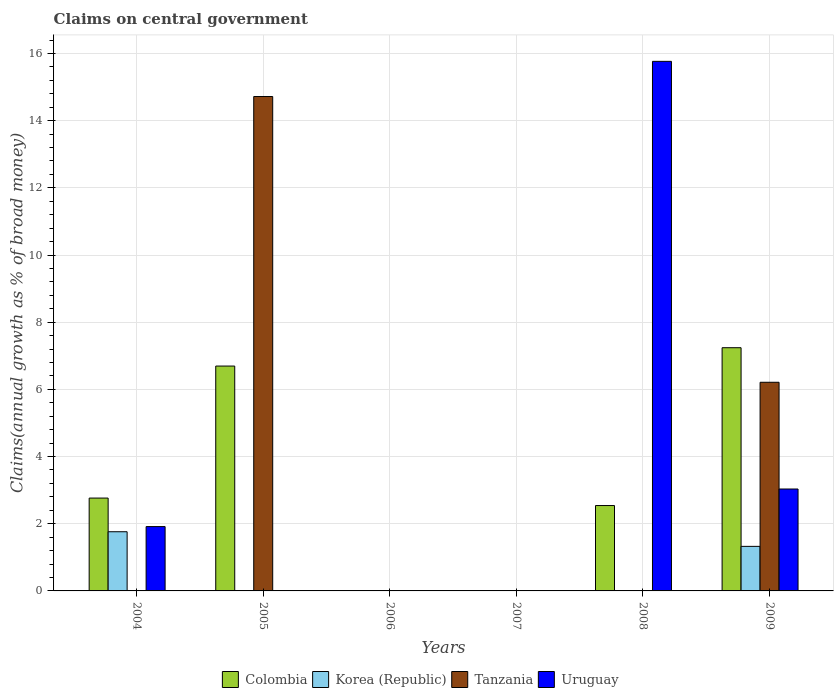How many different coloured bars are there?
Offer a terse response. 4. Are the number of bars per tick equal to the number of legend labels?
Your answer should be very brief. No. Are the number of bars on each tick of the X-axis equal?
Your answer should be compact. No. How many bars are there on the 4th tick from the right?
Your answer should be compact. 0. Across all years, what is the maximum percentage of broad money claimed on centeral government in Colombia?
Ensure brevity in your answer.  7.24. Across all years, what is the minimum percentage of broad money claimed on centeral government in Colombia?
Provide a short and direct response. 0. In which year was the percentage of broad money claimed on centeral government in Uruguay maximum?
Offer a very short reply. 2008. What is the total percentage of broad money claimed on centeral government in Tanzania in the graph?
Give a very brief answer. 20.93. What is the difference between the percentage of broad money claimed on centeral government in Uruguay in 2005 and the percentage of broad money claimed on centeral government in Colombia in 2006?
Your response must be concise. 0. What is the average percentage of broad money claimed on centeral government in Korea (Republic) per year?
Offer a terse response. 0.51. In the year 2009, what is the difference between the percentage of broad money claimed on centeral government in Colombia and percentage of broad money claimed on centeral government in Uruguay?
Provide a succinct answer. 4.21. In how many years, is the percentage of broad money claimed on centeral government in Korea (Republic) greater than 14 %?
Offer a very short reply. 0. What is the ratio of the percentage of broad money claimed on centeral government in Uruguay in 2004 to that in 2009?
Offer a very short reply. 0.63. What is the difference between the highest and the second highest percentage of broad money claimed on centeral government in Colombia?
Your answer should be very brief. 0.55. What is the difference between the highest and the lowest percentage of broad money claimed on centeral government in Uruguay?
Offer a very short reply. 15.77. In how many years, is the percentage of broad money claimed on centeral government in Korea (Republic) greater than the average percentage of broad money claimed on centeral government in Korea (Republic) taken over all years?
Provide a short and direct response. 2. How many bars are there?
Ensure brevity in your answer.  11. How many years are there in the graph?
Your answer should be compact. 6. Does the graph contain any zero values?
Your answer should be very brief. Yes. Does the graph contain grids?
Your answer should be very brief. Yes. Where does the legend appear in the graph?
Offer a terse response. Bottom center. How many legend labels are there?
Provide a succinct answer. 4. How are the legend labels stacked?
Provide a succinct answer. Horizontal. What is the title of the graph?
Make the answer very short. Claims on central government. What is the label or title of the Y-axis?
Your answer should be very brief. Claims(annual growth as % of broad money). What is the Claims(annual growth as % of broad money) of Colombia in 2004?
Ensure brevity in your answer.  2.76. What is the Claims(annual growth as % of broad money) in Korea (Republic) in 2004?
Keep it short and to the point. 1.76. What is the Claims(annual growth as % of broad money) of Uruguay in 2004?
Your answer should be compact. 1.92. What is the Claims(annual growth as % of broad money) in Colombia in 2005?
Provide a short and direct response. 6.69. What is the Claims(annual growth as % of broad money) in Korea (Republic) in 2005?
Offer a very short reply. 0. What is the Claims(annual growth as % of broad money) of Tanzania in 2005?
Offer a very short reply. 14.72. What is the Claims(annual growth as % of broad money) of Uruguay in 2005?
Offer a very short reply. 0. What is the Claims(annual growth as % of broad money) in Tanzania in 2006?
Offer a very short reply. 0. What is the Claims(annual growth as % of broad money) in Uruguay in 2007?
Your answer should be very brief. 0. What is the Claims(annual growth as % of broad money) of Colombia in 2008?
Keep it short and to the point. 2.54. What is the Claims(annual growth as % of broad money) of Uruguay in 2008?
Ensure brevity in your answer.  15.77. What is the Claims(annual growth as % of broad money) in Colombia in 2009?
Keep it short and to the point. 7.24. What is the Claims(annual growth as % of broad money) of Korea (Republic) in 2009?
Your answer should be very brief. 1.33. What is the Claims(annual growth as % of broad money) of Tanzania in 2009?
Your answer should be compact. 6.21. What is the Claims(annual growth as % of broad money) in Uruguay in 2009?
Make the answer very short. 3.03. Across all years, what is the maximum Claims(annual growth as % of broad money) in Colombia?
Offer a terse response. 7.24. Across all years, what is the maximum Claims(annual growth as % of broad money) of Korea (Republic)?
Ensure brevity in your answer.  1.76. Across all years, what is the maximum Claims(annual growth as % of broad money) of Tanzania?
Keep it short and to the point. 14.72. Across all years, what is the maximum Claims(annual growth as % of broad money) of Uruguay?
Your response must be concise. 15.77. Across all years, what is the minimum Claims(annual growth as % of broad money) of Korea (Republic)?
Your answer should be compact. 0. Across all years, what is the minimum Claims(annual growth as % of broad money) of Tanzania?
Make the answer very short. 0. What is the total Claims(annual growth as % of broad money) of Colombia in the graph?
Offer a very short reply. 19.24. What is the total Claims(annual growth as % of broad money) of Korea (Republic) in the graph?
Provide a succinct answer. 3.09. What is the total Claims(annual growth as % of broad money) of Tanzania in the graph?
Offer a very short reply. 20.93. What is the total Claims(annual growth as % of broad money) of Uruguay in the graph?
Provide a succinct answer. 20.71. What is the difference between the Claims(annual growth as % of broad money) in Colombia in 2004 and that in 2005?
Keep it short and to the point. -3.93. What is the difference between the Claims(annual growth as % of broad money) of Colombia in 2004 and that in 2008?
Your answer should be very brief. 0.22. What is the difference between the Claims(annual growth as % of broad money) in Uruguay in 2004 and that in 2008?
Make the answer very short. -13.85. What is the difference between the Claims(annual growth as % of broad money) in Colombia in 2004 and that in 2009?
Offer a terse response. -4.48. What is the difference between the Claims(annual growth as % of broad money) in Korea (Republic) in 2004 and that in 2009?
Your response must be concise. 0.44. What is the difference between the Claims(annual growth as % of broad money) in Uruguay in 2004 and that in 2009?
Your answer should be very brief. -1.12. What is the difference between the Claims(annual growth as % of broad money) in Colombia in 2005 and that in 2008?
Offer a very short reply. 4.15. What is the difference between the Claims(annual growth as % of broad money) of Colombia in 2005 and that in 2009?
Offer a very short reply. -0.55. What is the difference between the Claims(annual growth as % of broad money) in Tanzania in 2005 and that in 2009?
Your answer should be compact. 8.51. What is the difference between the Claims(annual growth as % of broad money) in Colombia in 2008 and that in 2009?
Give a very brief answer. -4.7. What is the difference between the Claims(annual growth as % of broad money) in Uruguay in 2008 and that in 2009?
Offer a terse response. 12.73. What is the difference between the Claims(annual growth as % of broad money) in Colombia in 2004 and the Claims(annual growth as % of broad money) in Tanzania in 2005?
Offer a very short reply. -11.95. What is the difference between the Claims(annual growth as % of broad money) in Korea (Republic) in 2004 and the Claims(annual growth as % of broad money) in Tanzania in 2005?
Your response must be concise. -12.96. What is the difference between the Claims(annual growth as % of broad money) of Colombia in 2004 and the Claims(annual growth as % of broad money) of Uruguay in 2008?
Keep it short and to the point. -13. What is the difference between the Claims(annual growth as % of broad money) in Korea (Republic) in 2004 and the Claims(annual growth as % of broad money) in Uruguay in 2008?
Provide a succinct answer. -14. What is the difference between the Claims(annual growth as % of broad money) in Colombia in 2004 and the Claims(annual growth as % of broad money) in Korea (Republic) in 2009?
Your response must be concise. 1.44. What is the difference between the Claims(annual growth as % of broad money) in Colombia in 2004 and the Claims(annual growth as % of broad money) in Tanzania in 2009?
Give a very brief answer. -3.45. What is the difference between the Claims(annual growth as % of broad money) of Colombia in 2004 and the Claims(annual growth as % of broad money) of Uruguay in 2009?
Give a very brief answer. -0.27. What is the difference between the Claims(annual growth as % of broad money) of Korea (Republic) in 2004 and the Claims(annual growth as % of broad money) of Tanzania in 2009?
Your answer should be compact. -4.45. What is the difference between the Claims(annual growth as % of broad money) in Korea (Republic) in 2004 and the Claims(annual growth as % of broad money) in Uruguay in 2009?
Provide a short and direct response. -1.27. What is the difference between the Claims(annual growth as % of broad money) in Colombia in 2005 and the Claims(annual growth as % of broad money) in Uruguay in 2008?
Make the answer very short. -9.07. What is the difference between the Claims(annual growth as % of broad money) of Tanzania in 2005 and the Claims(annual growth as % of broad money) of Uruguay in 2008?
Your answer should be very brief. -1.05. What is the difference between the Claims(annual growth as % of broad money) in Colombia in 2005 and the Claims(annual growth as % of broad money) in Korea (Republic) in 2009?
Ensure brevity in your answer.  5.37. What is the difference between the Claims(annual growth as % of broad money) of Colombia in 2005 and the Claims(annual growth as % of broad money) of Tanzania in 2009?
Offer a terse response. 0.48. What is the difference between the Claims(annual growth as % of broad money) of Colombia in 2005 and the Claims(annual growth as % of broad money) of Uruguay in 2009?
Your answer should be compact. 3.66. What is the difference between the Claims(annual growth as % of broad money) of Tanzania in 2005 and the Claims(annual growth as % of broad money) of Uruguay in 2009?
Offer a very short reply. 11.68. What is the difference between the Claims(annual growth as % of broad money) of Colombia in 2008 and the Claims(annual growth as % of broad money) of Korea (Republic) in 2009?
Make the answer very short. 1.22. What is the difference between the Claims(annual growth as % of broad money) in Colombia in 2008 and the Claims(annual growth as % of broad money) in Tanzania in 2009?
Provide a succinct answer. -3.67. What is the difference between the Claims(annual growth as % of broad money) of Colombia in 2008 and the Claims(annual growth as % of broad money) of Uruguay in 2009?
Your answer should be very brief. -0.49. What is the average Claims(annual growth as % of broad money) in Colombia per year?
Make the answer very short. 3.21. What is the average Claims(annual growth as % of broad money) of Korea (Republic) per year?
Ensure brevity in your answer.  0.51. What is the average Claims(annual growth as % of broad money) of Tanzania per year?
Your answer should be very brief. 3.49. What is the average Claims(annual growth as % of broad money) in Uruguay per year?
Ensure brevity in your answer.  3.45. In the year 2004, what is the difference between the Claims(annual growth as % of broad money) of Colombia and Claims(annual growth as % of broad money) of Korea (Republic)?
Offer a terse response. 1. In the year 2004, what is the difference between the Claims(annual growth as % of broad money) of Colombia and Claims(annual growth as % of broad money) of Uruguay?
Offer a terse response. 0.85. In the year 2004, what is the difference between the Claims(annual growth as % of broad money) of Korea (Republic) and Claims(annual growth as % of broad money) of Uruguay?
Offer a terse response. -0.15. In the year 2005, what is the difference between the Claims(annual growth as % of broad money) of Colombia and Claims(annual growth as % of broad money) of Tanzania?
Your answer should be very brief. -8.02. In the year 2008, what is the difference between the Claims(annual growth as % of broad money) of Colombia and Claims(annual growth as % of broad money) of Uruguay?
Offer a terse response. -13.22. In the year 2009, what is the difference between the Claims(annual growth as % of broad money) in Colombia and Claims(annual growth as % of broad money) in Korea (Republic)?
Provide a succinct answer. 5.91. In the year 2009, what is the difference between the Claims(annual growth as % of broad money) of Colombia and Claims(annual growth as % of broad money) of Tanzania?
Offer a terse response. 1.03. In the year 2009, what is the difference between the Claims(annual growth as % of broad money) of Colombia and Claims(annual growth as % of broad money) of Uruguay?
Your answer should be very brief. 4.21. In the year 2009, what is the difference between the Claims(annual growth as % of broad money) in Korea (Republic) and Claims(annual growth as % of broad money) in Tanzania?
Give a very brief answer. -4.89. In the year 2009, what is the difference between the Claims(annual growth as % of broad money) in Korea (Republic) and Claims(annual growth as % of broad money) in Uruguay?
Provide a succinct answer. -1.71. In the year 2009, what is the difference between the Claims(annual growth as % of broad money) of Tanzania and Claims(annual growth as % of broad money) of Uruguay?
Offer a very short reply. 3.18. What is the ratio of the Claims(annual growth as % of broad money) in Colombia in 2004 to that in 2005?
Keep it short and to the point. 0.41. What is the ratio of the Claims(annual growth as % of broad money) in Colombia in 2004 to that in 2008?
Make the answer very short. 1.09. What is the ratio of the Claims(annual growth as % of broad money) of Uruguay in 2004 to that in 2008?
Your answer should be compact. 0.12. What is the ratio of the Claims(annual growth as % of broad money) in Colombia in 2004 to that in 2009?
Offer a terse response. 0.38. What is the ratio of the Claims(annual growth as % of broad money) in Korea (Republic) in 2004 to that in 2009?
Your response must be concise. 1.33. What is the ratio of the Claims(annual growth as % of broad money) of Uruguay in 2004 to that in 2009?
Your response must be concise. 0.63. What is the ratio of the Claims(annual growth as % of broad money) in Colombia in 2005 to that in 2008?
Provide a short and direct response. 2.63. What is the ratio of the Claims(annual growth as % of broad money) in Colombia in 2005 to that in 2009?
Your answer should be very brief. 0.92. What is the ratio of the Claims(annual growth as % of broad money) in Tanzania in 2005 to that in 2009?
Keep it short and to the point. 2.37. What is the ratio of the Claims(annual growth as % of broad money) of Colombia in 2008 to that in 2009?
Ensure brevity in your answer.  0.35. What is the ratio of the Claims(annual growth as % of broad money) of Uruguay in 2008 to that in 2009?
Give a very brief answer. 5.2. What is the difference between the highest and the second highest Claims(annual growth as % of broad money) of Colombia?
Your response must be concise. 0.55. What is the difference between the highest and the second highest Claims(annual growth as % of broad money) in Uruguay?
Offer a very short reply. 12.73. What is the difference between the highest and the lowest Claims(annual growth as % of broad money) of Colombia?
Provide a succinct answer. 7.24. What is the difference between the highest and the lowest Claims(annual growth as % of broad money) in Korea (Republic)?
Ensure brevity in your answer.  1.76. What is the difference between the highest and the lowest Claims(annual growth as % of broad money) of Tanzania?
Offer a very short reply. 14.72. What is the difference between the highest and the lowest Claims(annual growth as % of broad money) of Uruguay?
Offer a terse response. 15.77. 